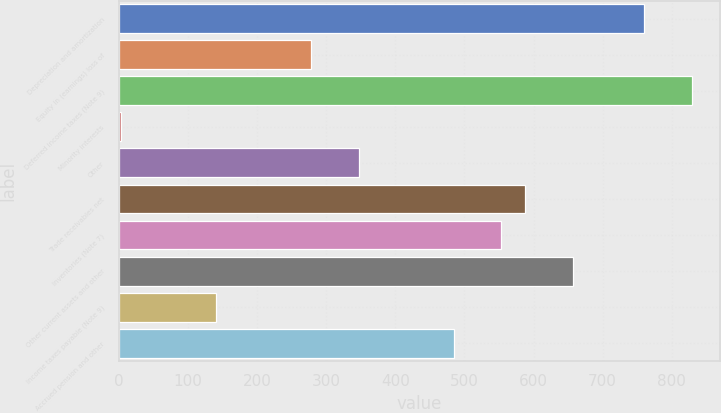Convert chart to OTSL. <chart><loc_0><loc_0><loc_500><loc_500><bar_chart><fcel>Depreciation and amortization<fcel>Equity in (earnings) loss of<fcel>Deferred income taxes (Note 9)<fcel>Minority interests<fcel>Other<fcel>Trade receivables net<fcel>Inventories (Note 7)<fcel>Other current assets and other<fcel>Income taxes payable (Note 9)<fcel>Accrued pension and other<nl><fcel>759.98<fcel>277.82<fcel>828.86<fcel>2.3<fcel>346.7<fcel>587.78<fcel>553.34<fcel>656.66<fcel>140.06<fcel>484.46<nl></chart> 